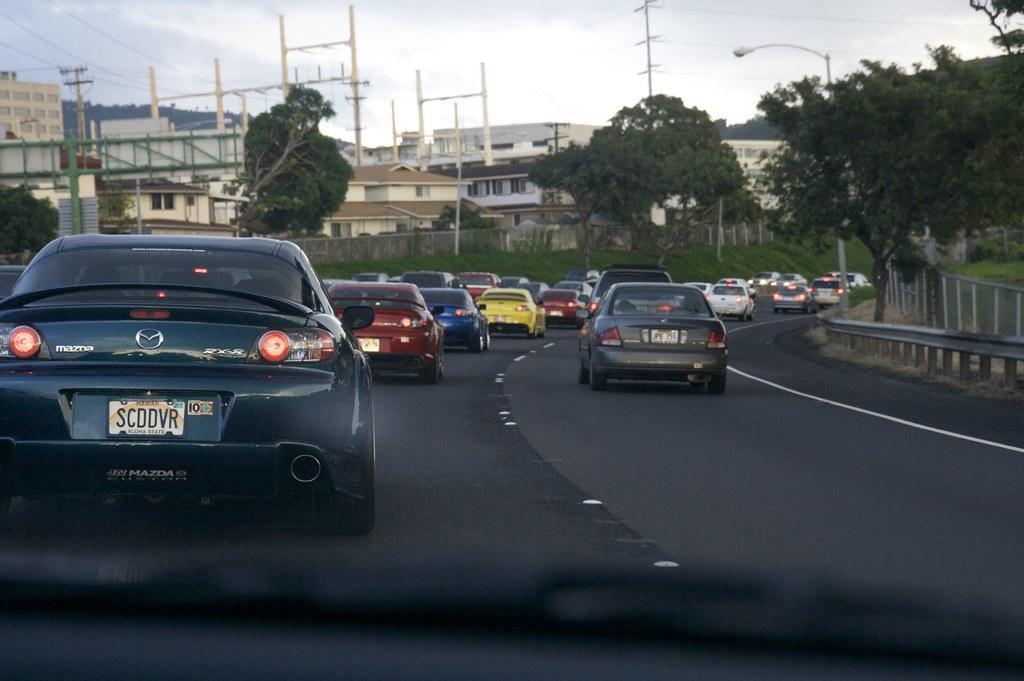Please provide a concise description of this image. In this image there are vehicles on the road. Right side there is a fence. Right side there is a street light. There are poles connected with wires. Left side there is a board attached to the pole. Background there are trees and buildings. Top of the image there is sky. There is a fence on the grassland. 